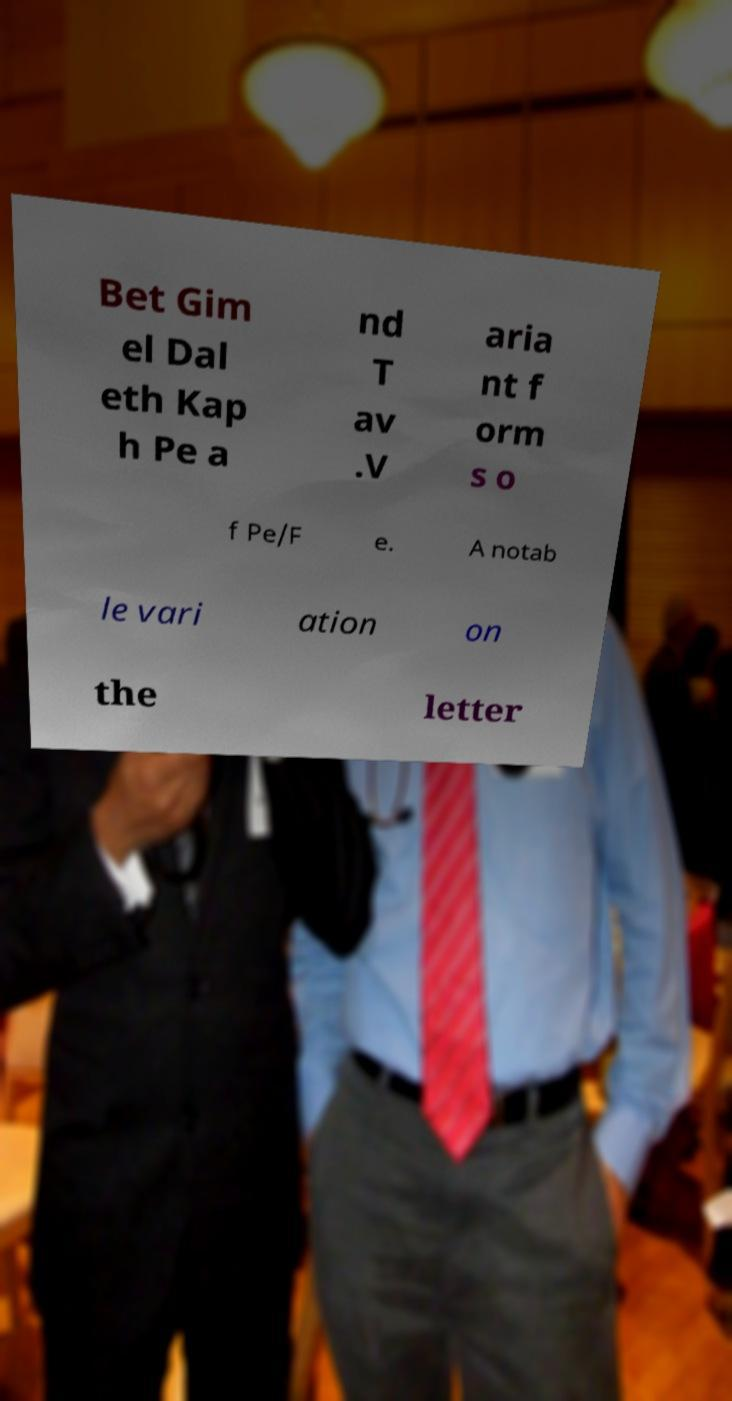What messages or text are displayed in this image? I need them in a readable, typed format. Bet Gim el Dal eth Kap h Pe a nd T av .V aria nt f orm s o f Pe/F e. A notab le vari ation on the letter 